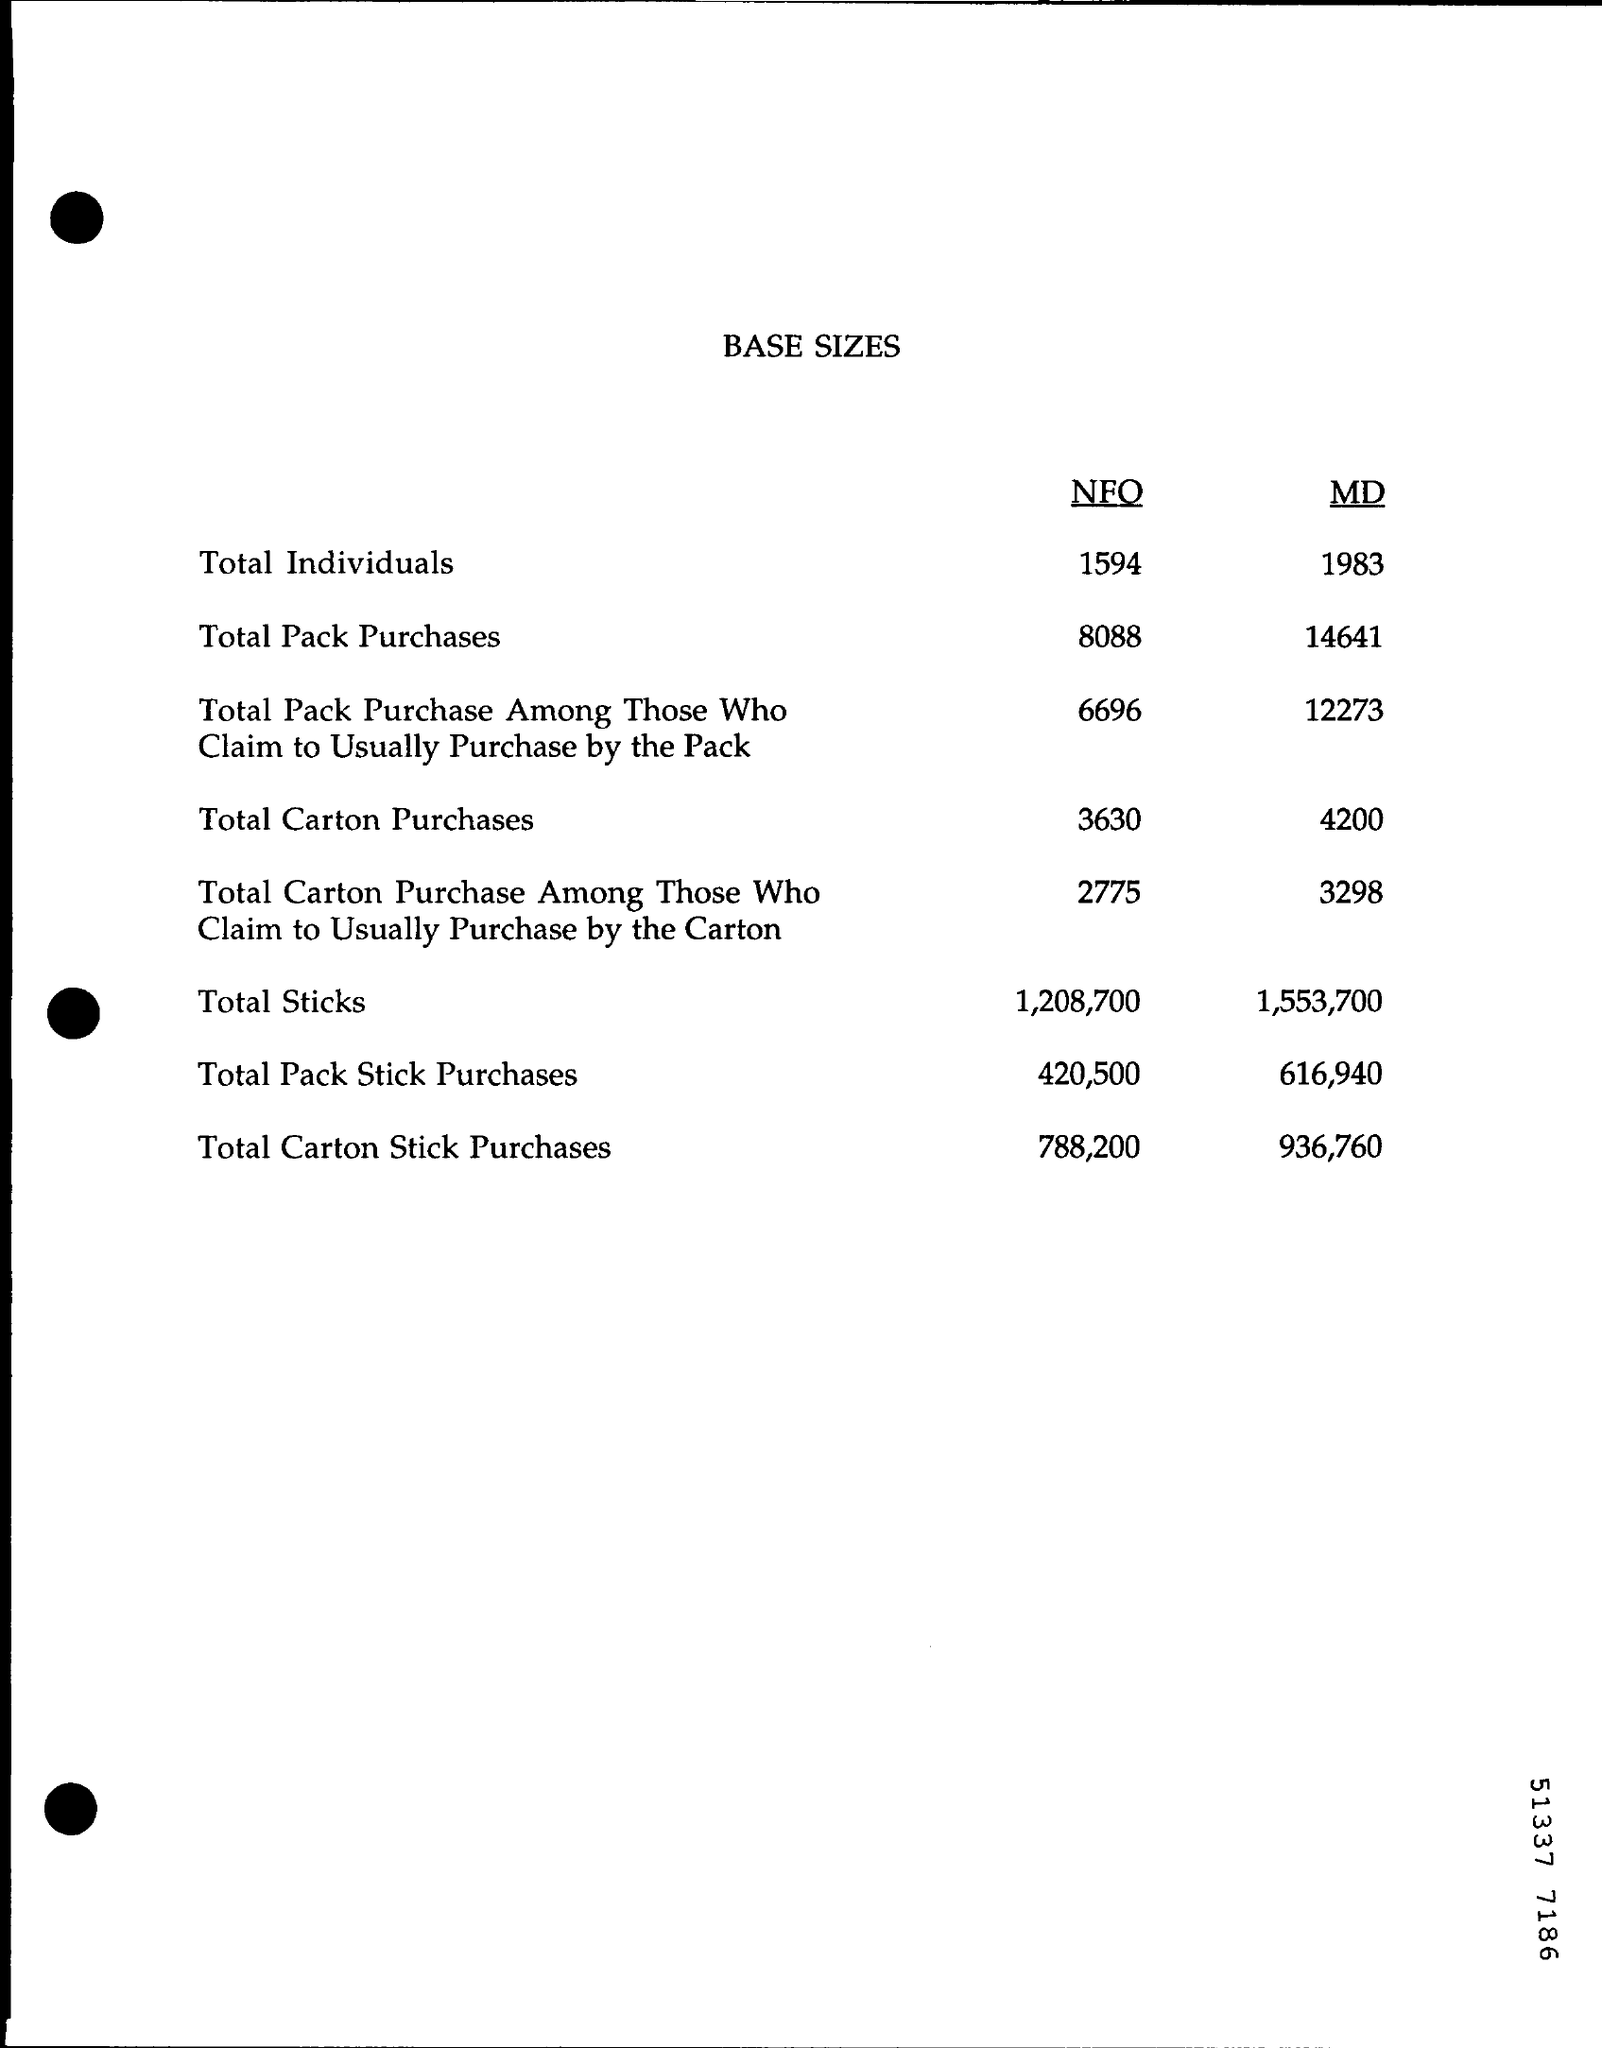What is the document title?
Your response must be concise. BASE SIZES. What is the Total Carton Purchases under NFO?
Make the answer very short. 3630. What is the Total Pack Sticks Purchases under MD?
Provide a succinct answer. 616,940. 